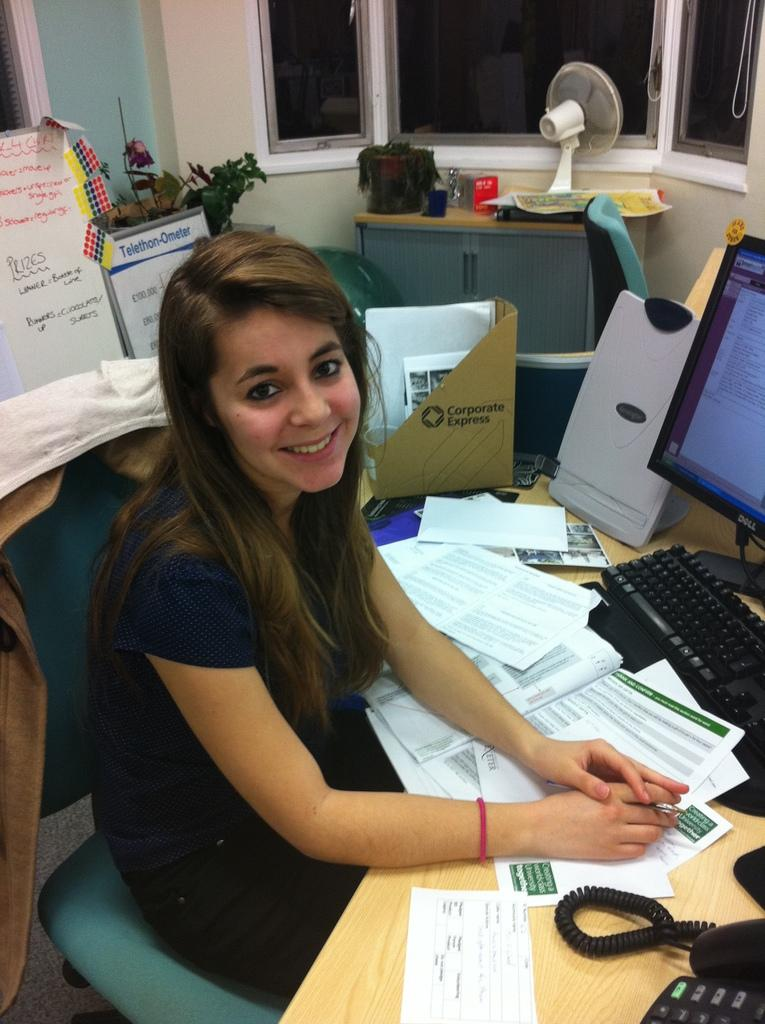<image>
Relay a brief, clear account of the picture shown. A young woman sits at a desk with papers scattered about and a Corporate Express stand up box storing some items. 